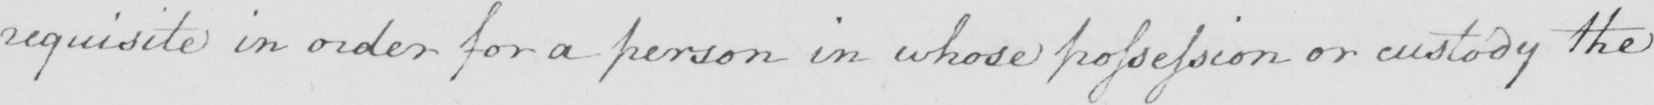Can you tell me what this handwritten text says? requisite in order for a person in whose possession or custody the 